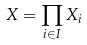<formula> <loc_0><loc_0><loc_500><loc_500>X = \prod _ { i \in I } X _ { i }</formula> 